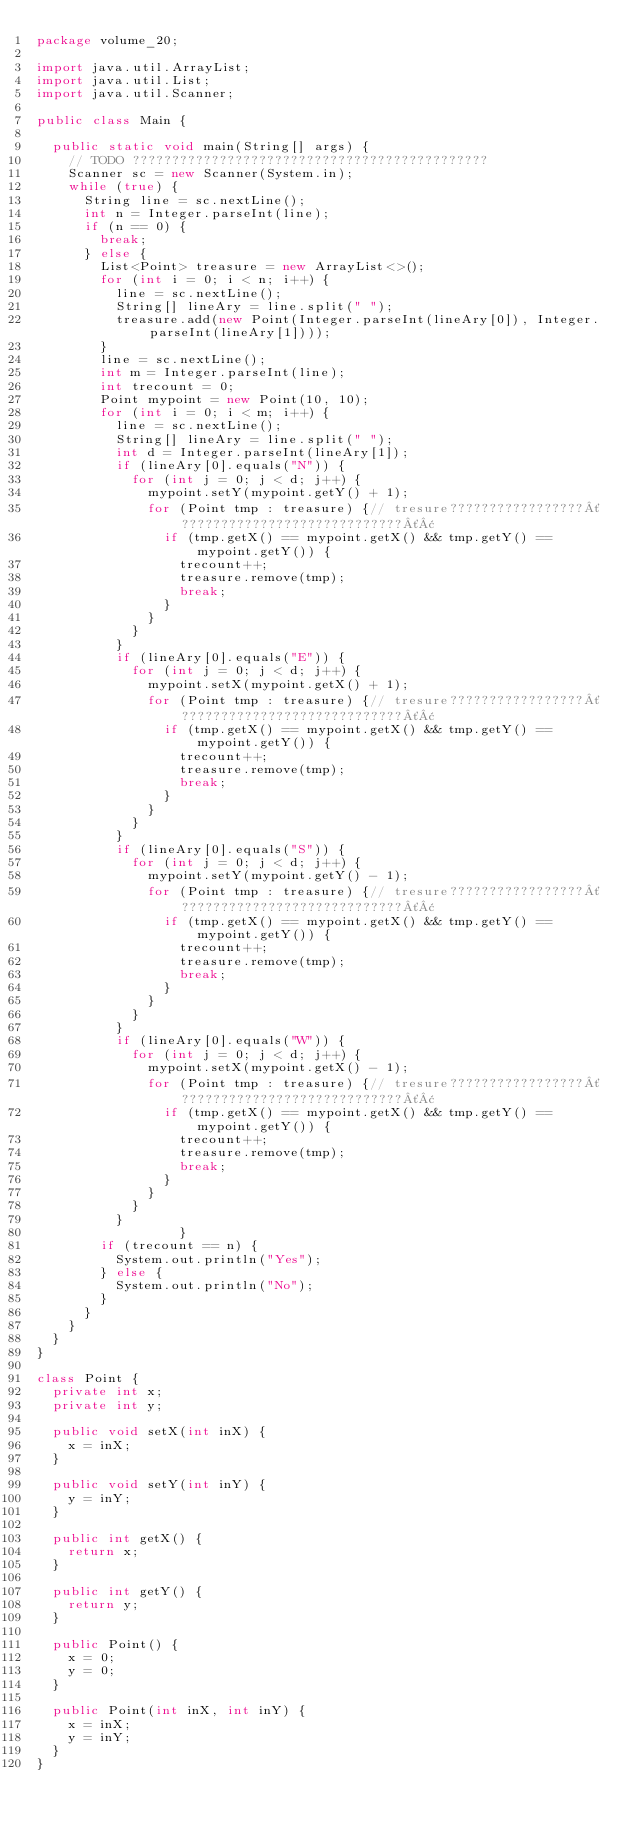Convert code to text. <code><loc_0><loc_0><loc_500><loc_500><_Java_>package volume_20;

import java.util.ArrayList;
import java.util.List;
import java.util.Scanner;

public class Main {

	public static void main(String[] args) {
		// TODO ?????????????????????????????????????????????
		Scanner sc = new Scanner(System.in);
		while (true) {
			String line = sc.nextLine();
			int n = Integer.parseInt(line);
			if (n == 0) {
				break;
			} else {
				List<Point> treasure = new ArrayList<>();
				for (int i = 0; i < n; i++) {
					line = sc.nextLine();
					String[] lineAry = line.split(" ");
					treasure.add(new Point(Integer.parseInt(lineAry[0]), Integer.parseInt(lineAry[1])));
				}
				line = sc.nextLine();
				int m = Integer.parseInt(line);
				int trecount = 0;
				Point mypoint = new Point(10, 10);
				for (int i = 0; i < m; i++) {
					line = sc.nextLine();
					String[] lineAry = line.split(" ");
					int d = Integer.parseInt(lineAry[1]);
					if (lineAry[0].equals("N")) {
						for (int j = 0; j < d; j++) {
							mypoint.setY(mypoint.getY() + 1);
							for (Point tmp : treasure) {// tresure?????????????????´????????????????????????????´¢
								if (tmp.getX() == mypoint.getX() && tmp.getY() == mypoint.getY()) {
									trecount++;
									treasure.remove(tmp);
									break;
								}
							}
						}
					}
					if (lineAry[0].equals("E")) {
						for (int j = 0; j < d; j++) {
							mypoint.setX(mypoint.getX() + 1);
							for (Point tmp : treasure) {// tresure?????????????????´????????????????????????????´¢
								if (tmp.getX() == mypoint.getX() && tmp.getY() == mypoint.getY()) {
									trecount++;
									treasure.remove(tmp);
									break;
								}
							}
						}
					}
					if (lineAry[0].equals("S")) {
						for (int j = 0; j < d; j++) {
							mypoint.setY(mypoint.getY() - 1);
							for (Point tmp : treasure) {// tresure?????????????????´????????????????????????????´¢
								if (tmp.getX() == mypoint.getX() && tmp.getY() == mypoint.getY()) {
									trecount++;
									treasure.remove(tmp);
									break;
								}
							}
						}
					}
					if (lineAry[0].equals("W")) {
						for (int j = 0; j < d; j++) {
							mypoint.setX(mypoint.getX() - 1);
							for (Point tmp : treasure) {// tresure?????????????????´????????????????????????????´¢
								if (tmp.getX() == mypoint.getX() && tmp.getY() == mypoint.getY()) {
									trecount++;
									treasure.remove(tmp);
									break;
								}
							}
						}
					}
									}
				if (trecount == n) {
					System.out.println("Yes");
				} else {
					System.out.println("No");
				}
			}
		}
	}
}

class Point {
	private int x;
	private int y;

	public void setX(int inX) {
		x = inX;
	}

	public void setY(int inY) {
		y = inY;
	}

	public int getX() {
		return x;
	}

	public int getY() {
		return y;
	}

	public Point() {
		x = 0;
		y = 0;
	}

	public Point(int inX, int inY) {
		x = inX;
		y = inY;
	}
}</code> 